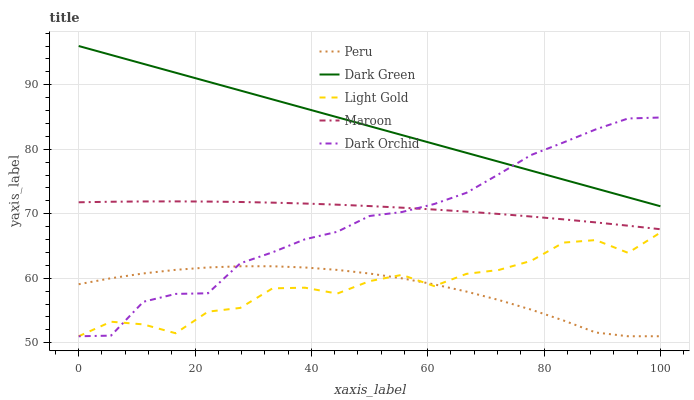Does Peru have the minimum area under the curve?
Answer yes or no. Yes. Does Dark Green have the maximum area under the curve?
Answer yes or no. Yes. Does Light Gold have the minimum area under the curve?
Answer yes or no. No. Does Light Gold have the maximum area under the curve?
Answer yes or no. No. Is Dark Green the smoothest?
Answer yes or no. Yes. Is Light Gold the roughest?
Answer yes or no. Yes. Is Maroon the smoothest?
Answer yes or no. No. Is Maroon the roughest?
Answer yes or no. No. Does Dark Orchid have the lowest value?
Answer yes or no. Yes. Does Maroon have the lowest value?
Answer yes or no. No. Does Dark Green have the highest value?
Answer yes or no. Yes. Does Light Gold have the highest value?
Answer yes or no. No. Is Light Gold less than Dark Green?
Answer yes or no. Yes. Is Maroon greater than Light Gold?
Answer yes or no. Yes. Does Dark Orchid intersect Dark Green?
Answer yes or no. Yes. Is Dark Orchid less than Dark Green?
Answer yes or no. No. Is Dark Orchid greater than Dark Green?
Answer yes or no. No. Does Light Gold intersect Dark Green?
Answer yes or no. No. 